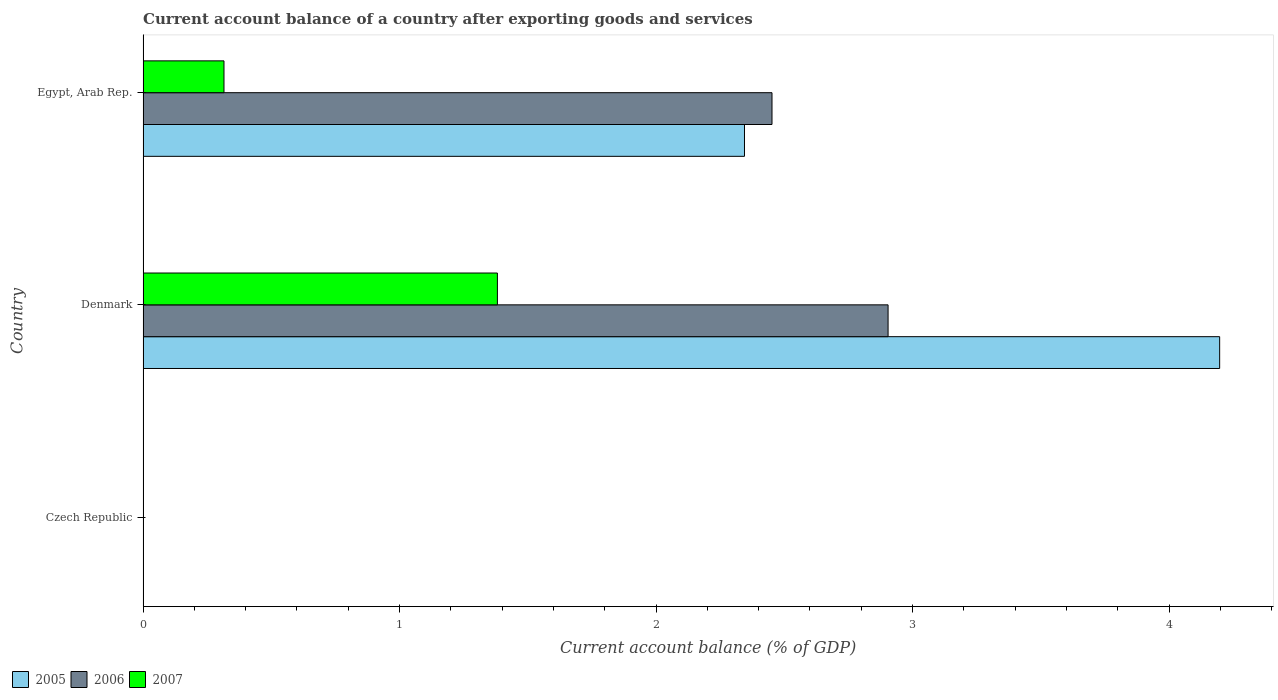Are the number of bars on each tick of the Y-axis equal?
Your answer should be compact. No. What is the label of the 1st group of bars from the top?
Give a very brief answer. Egypt, Arab Rep. Across all countries, what is the maximum account balance in 2007?
Ensure brevity in your answer.  1.38. Across all countries, what is the minimum account balance in 2006?
Make the answer very short. 0. In which country was the account balance in 2005 maximum?
Provide a short and direct response. Denmark. What is the total account balance in 2006 in the graph?
Offer a terse response. 5.36. What is the difference between the account balance in 2005 in Denmark and that in Egypt, Arab Rep.?
Your response must be concise. 1.85. What is the difference between the account balance in 2005 in Denmark and the account balance in 2006 in Egypt, Arab Rep.?
Provide a succinct answer. 1.75. What is the average account balance in 2006 per country?
Give a very brief answer. 1.79. What is the difference between the account balance in 2006 and account balance in 2007 in Denmark?
Provide a succinct answer. 1.52. In how many countries, is the account balance in 2006 greater than 3.6 %?
Keep it short and to the point. 0. What is the ratio of the account balance in 2007 in Denmark to that in Egypt, Arab Rep.?
Your answer should be compact. 4.38. Is the account balance in 2005 in Denmark less than that in Egypt, Arab Rep.?
Offer a terse response. No. Is the difference between the account balance in 2006 in Denmark and Egypt, Arab Rep. greater than the difference between the account balance in 2007 in Denmark and Egypt, Arab Rep.?
Offer a terse response. No. What is the difference between the highest and the lowest account balance in 2006?
Make the answer very short. 2.9. Is the sum of the account balance in 2006 in Denmark and Egypt, Arab Rep. greater than the maximum account balance in 2007 across all countries?
Provide a short and direct response. Yes. How many bars are there?
Offer a terse response. 6. Are all the bars in the graph horizontal?
Your answer should be compact. Yes. Does the graph contain any zero values?
Provide a short and direct response. Yes. Where does the legend appear in the graph?
Provide a succinct answer. Bottom left. How many legend labels are there?
Provide a short and direct response. 3. What is the title of the graph?
Offer a very short reply. Current account balance of a country after exporting goods and services. Does "1963" appear as one of the legend labels in the graph?
Provide a succinct answer. No. What is the label or title of the X-axis?
Provide a succinct answer. Current account balance (% of GDP). What is the Current account balance (% of GDP) of 2006 in Czech Republic?
Provide a short and direct response. 0. What is the Current account balance (% of GDP) of 2007 in Czech Republic?
Your answer should be very brief. 0. What is the Current account balance (% of GDP) of 2005 in Denmark?
Your answer should be compact. 4.2. What is the Current account balance (% of GDP) in 2006 in Denmark?
Provide a short and direct response. 2.9. What is the Current account balance (% of GDP) of 2007 in Denmark?
Offer a very short reply. 1.38. What is the Current account balance (% of GDP) of 2005 in Egypt, Arab Rep.?
Ensure brevity in your answer.  2.34. What is the Current account balance (% of GDP) in 2006 in Egypt, Arab Rep.?
Give a very brief answer. 2.45. What is the Current account balance (% of GDP) of 2007 in Egypt, Arab Rep.?
Provide a short and direct response. 0.32. Across all countries, what is the maximum Current account balance (% of GDP) in 2005?
Your response must be concise. 4.2. Across all countries, what is the maximum Current account balance (% of GDP) of 2006?
Keep it short and to the point. 2.9. Across all countries, what is the maximum Current account balance (% of GDP) in 2007?
Give a very brief answer. 1.38. Across all countries, what is the minimum Current account balance (% of GDP) of 2005?
Your answer should be compact. 0. Across all countries, what is the minimum Current account balance (% of GDP) in 2006?
Provide a succinct answer. 0. What is the total Current account balance (% of GDP) in 2005 in the graph?
Your answer should be very brief. 6.54. What is the total Current account balance (% of GDP) in 2006 in the graph?
Offer a very short reply. 5.36. What is the total Current account balance (% of GDP) of 2007 in the graph?
Make the answer very short. 1.7. What is the difference between the Current account balance (% of GDP) in 2005 in Denmark and that in Egypt, Arab Rep.?
Your answer should be very brief. 1.85. What is the difference between the Current account balance (% of GDP) in 2006 in Denmark and that in Egypt, Arab Rep.?
Your response must be concise. 0.45. What is the difference between the Current account balance (% of GDP) in 2007 in Denmark and that in Egypt, Arab Rep.?
Offer a terse response. 1.07. What is the difference between the Current account balance (% of GDP) of 2005 in Denmark and the Current account balance (% of GDP) of 2006 in Egypt, Arab Rep.?
Your answer should be compact. 1.75. What is the difference between the Current account balance (% of GDP) of 2005 in Denmark and the Current account balance (% of GDP) of 2007 in Egypt, Arab Rep.?
Ensure brevity in your answer.  3.88. What is the difference between the Current account balance (% of GDP) of 2006 in Denmark and the Current account balance (% of GDP) of 2007 in Egypt, Arab Rep.?
Offer a very short reply. 2.59. What is the average Current account balance (% of GDP) in 2005 per country?
Ensure brevity in your answer.  2.18. What is the average Current account balance (% of GDP) of 2006 per country?
Give a very brief answer. 1.79. What is the average Current account balance (% of GDP) in 2007 per country?
Offer a terse response. 0.57. What is the difference between the Current account balance (% of GDP) in 2005 and Current account balance (% of GDP) in 2006 in Denmark?
Give a very brief answer. 1.29. What is the difference between the Current account balance (% of GDP) of 2005 and Current account balance (% of GDP) of 2007 in Denmark?
Your response must be concise. 2.82. What is the difference between the Current account balance (% of GDP) in 2006 and Current account balance (% of GDP) in 2007 in Denmark?
Give a very brief answer. 1.52. What is the difference between the Current account balance (% of GDP) of 2005 and Current account balance (% of GDP) of 2006 in Egypt, Arab Rep.?
Provide a short and direct response. -0.11. What is the difference between the Current account balance (% of GDP) in 2005 and Current account balance (% of GDP) in 2007 in Egypt, Arab Rep.?
Provide a succinct answer. 2.03. What is the difference between the Current account balance (% of GDP) of 2006 and Current account balance (% of GDP) of 2007 in Egypt, Arab Rep.?
Make the answer very short. 2.14. What is the ratio of the Current account balance (% of GDP) in 2005 in Denmark to that in Egypt, Arab Rep.?
Keep it short and to the point. 1.79. What is the ratio of the Current account balance (% of GDP) of 2006 in Denmark to that in Egypt, Arab Rep.?
Give a very brief answer. 1.18. What is the ratio of the Current account balance (% of GDP) of 2007 in Denmark to that in Egypt, Arab Rep.?
Your response must be concise. 4.38. What is the difference between the highest and the lowest Current account balance (% of GDP) of 2005?
Offer a terse response. 4.2. What is the difference between the highest and the lowest Current account balance (% of GDP) of 2006?
Ensure brevity in your answer.  2.9. What is the difference between the highest and the lowest Current account balance (% of GDP) of 2007?
Your answer should be very brief. 1.38. 